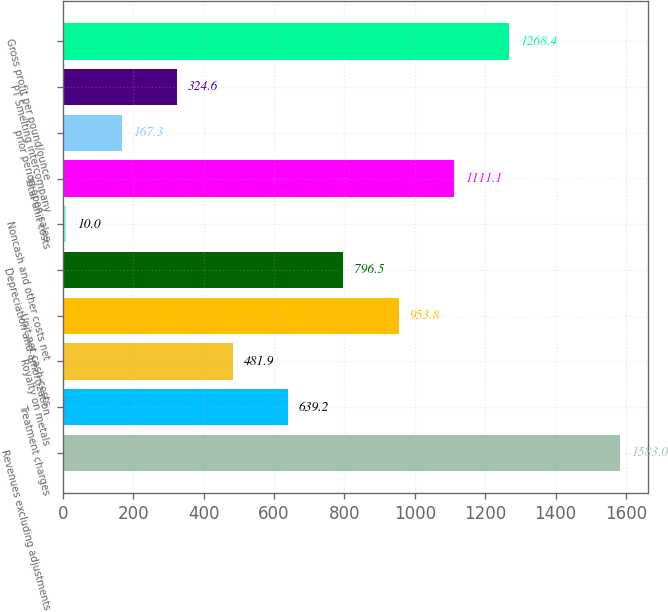Convert chart. <chart><loc_0><loc_0><loc_500><loc_500><bar_chart><fcel>Revenues excluding adjustments<fcel>Treatment charges<fcel>Royalty on metals<fcel>Unit net cash costs<fcel>Depreciation and amortization<fcel>Noncash and other costs net<fcel>Total unit costs<fcel>prior period open sales<fcel>PT Smelting intercompany<fcel>Gross profit per pound/ounce<nl><fcel>1583<fcel>639.2<fcel>481.9<fcel>953.8<fcel>796.5<fcel>10<fcel>1111.1<fcel>167.3<fcel>324.6<fcel>1268.4<nl></chart> 